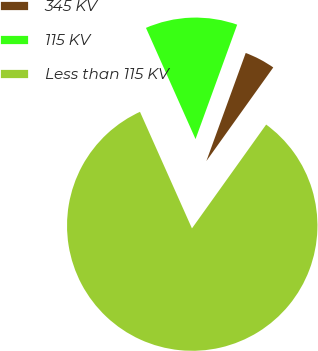Convert chart to OTSL. <chart><loc_0><loc_0><loc_500><loc_500><pie_chart><fcel>345 KV<fcel>115 KV<fcel>Less than 115 KV<nl><fcel>4.32%<fcel>12.23%<fcel>83.45%<nl></chart> 